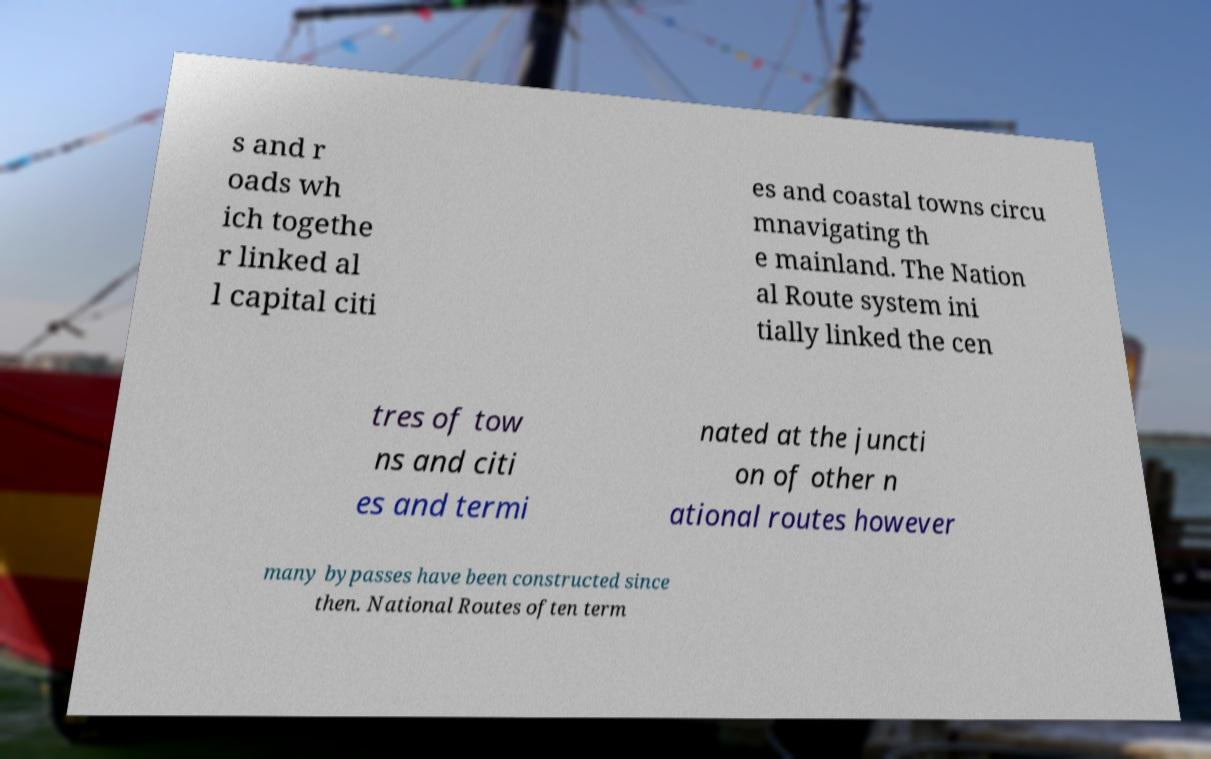Please identify and transcribe the text found in this image. s and r oads wh ich togethe r linked al l capital citi es and coastal towns circu mnavigating th e mainland. The Nation al Route system ini tially linked the cen tres of tow ns and citi es and termi nated at the juncti on of other n ational routes however many bypasses have been constructed since then. National Routes often term 